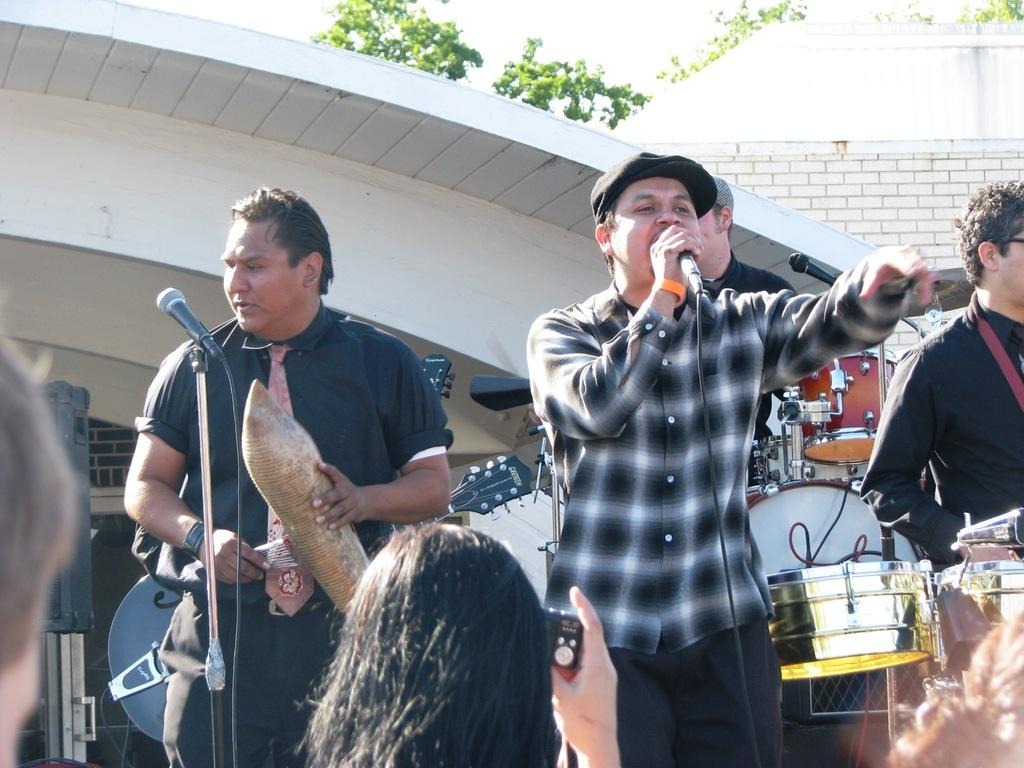How many people are in the image? There are people standing in the image. What is one person doing in the image? One person is holding a mic. What can be seen in the background of the image? There is a drum set, a building, and a tree in the background of the image. What color is the steam coming out of the person's mind in the image? There is no steam or reference to a person's mind in the image. 